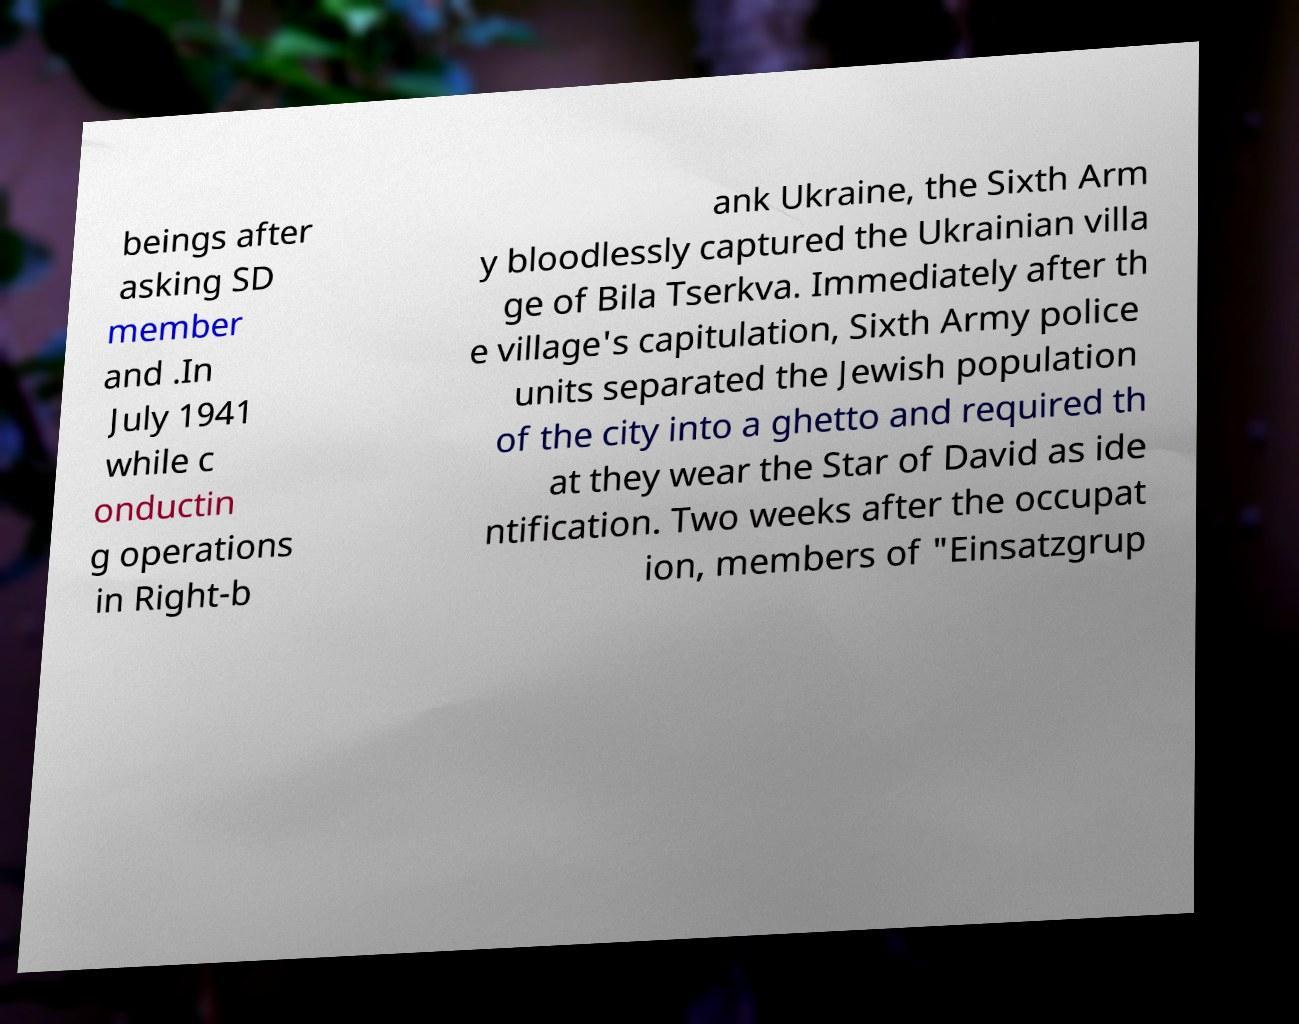There's text embedded in this image that I need extracted. Can you transcribe it verbatim? beings after asking SD member and .In July 1941 while c onductin g operations in Right-b ank Ukraine, the Sixth Arm y bloodlessly captured the Ukrainian villa ge of Bila Tserkva. Immediately after th e village's capitulation, Sixth Army police units separated the Jewish population of the city into a ghetto and required th at they wear the Star of David as ide ntification. Two weeks after the occupat ion, members of "Einsatzgrup 